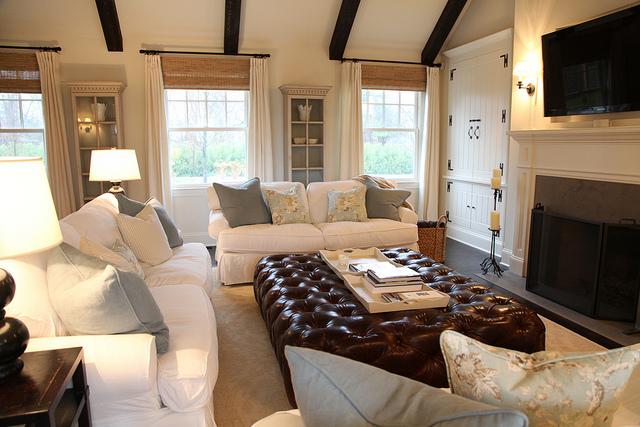What keeps embers inside the fireplace?
Give a very brief answer. Screen. Is it daytime?
Write a very short answer. Yes. Lamps are in this room?
Keep it brief. Yes. 